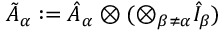Convert formula to latex. <formula><loc_0><loc_0><loc_500><loc_500>\tilde { A } _ { \alpha } \colon = \hat { A } _ { \alpha } \otimes ( \otimes _ { \beta \neq \alpha } \hat { I } _ { \beta } )</formula> 